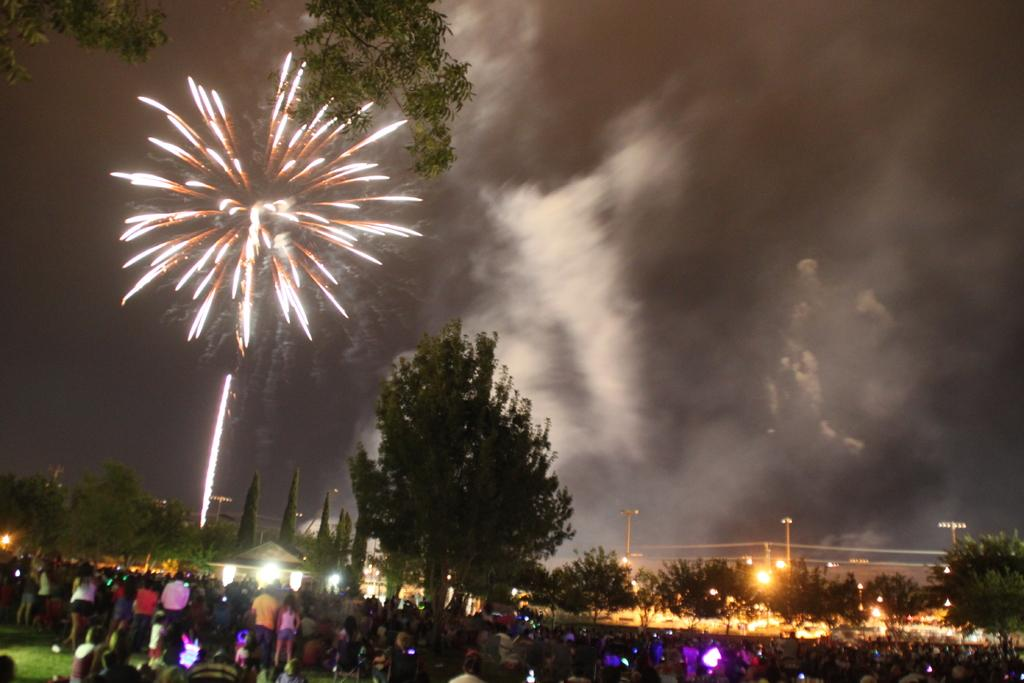How many people are in the image? There is a group of people in the image, but the exact number is not specified. What can be seen in the image besides the people? There are lights, trees, poles, smoke, and fireworks visible in the image. What is the background of the image like? The background of the image includes trees, poles, smoke, and fireworks. What might be happening in the image? The presence of lights, fireworks, and a group of people suggests that there might be a celebration or event taking place. What type of engine can be seen in the image? There is no engine present in the image. What is being served for dinner in the image? There is no dinner or food being served in the image. 